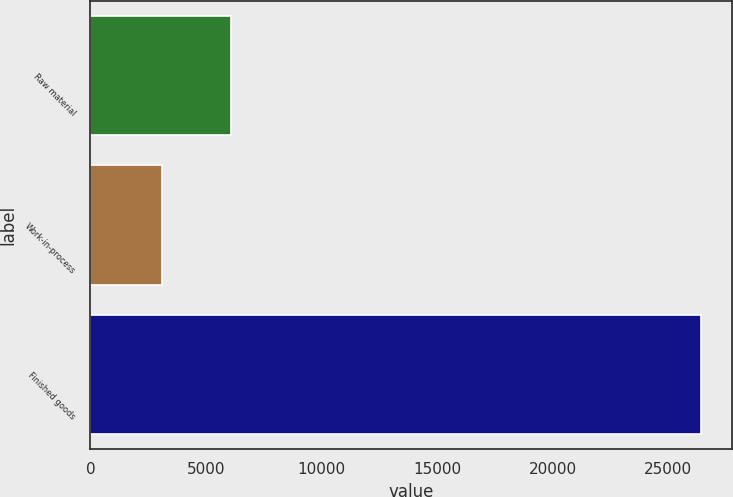<chart> <loc_0><loc_0><loc_500><loc_500><bar_chart><fcel>Raw material<fcel>Work-in-process<fcel>Finished goods<nl><fcel>6093<fcel>3089<fcel>26426<nl></chart> 